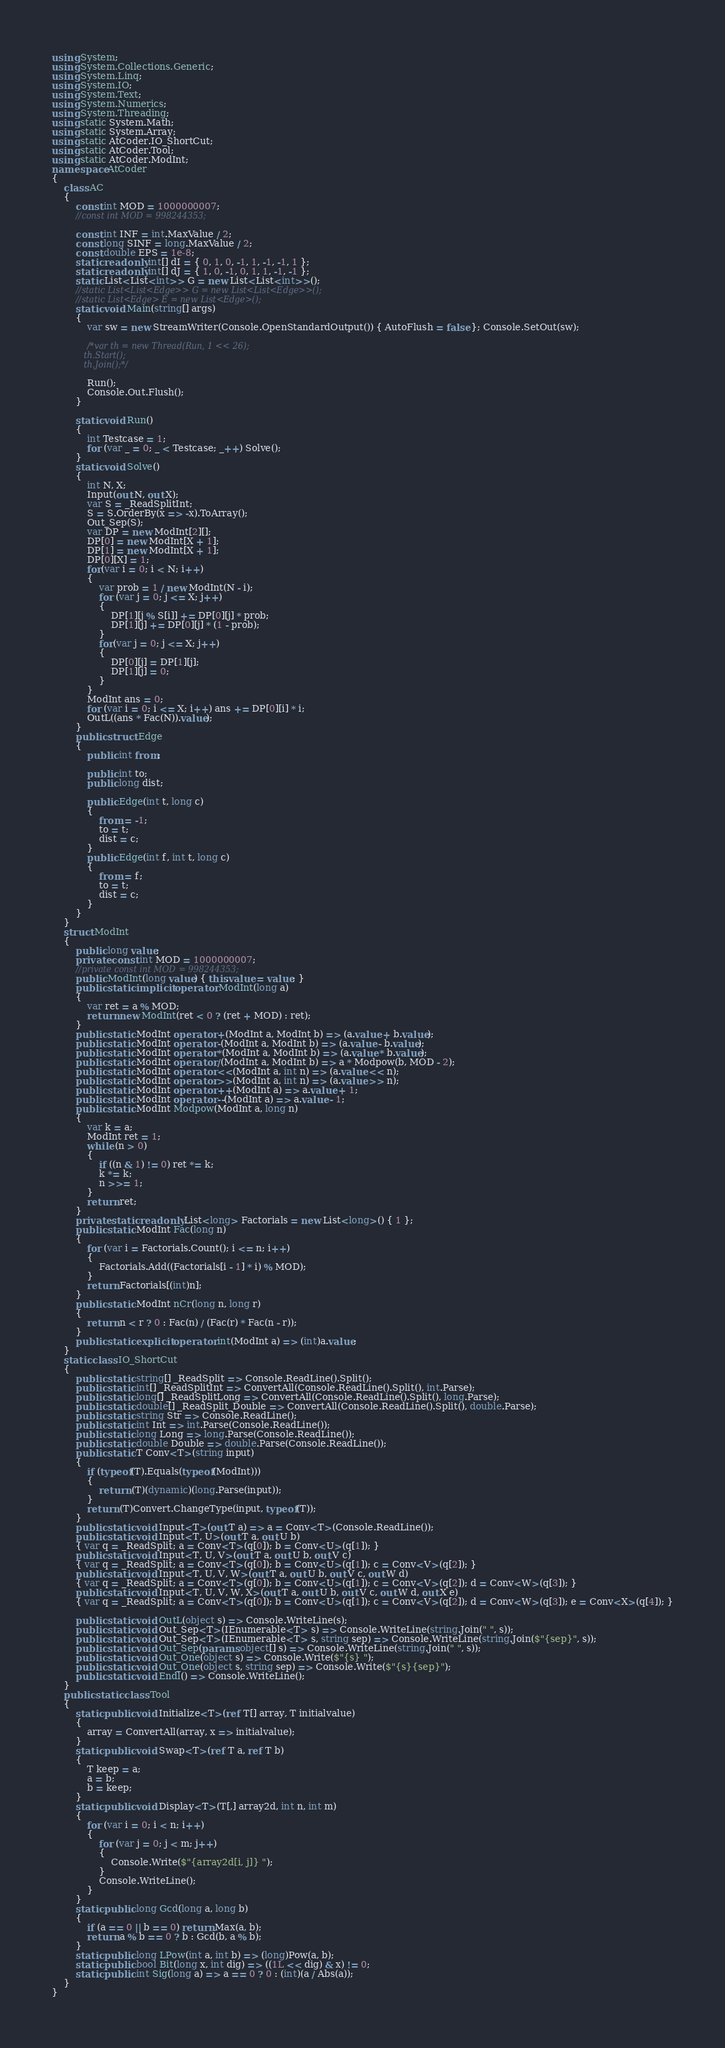Convert code to text. <code><loc_0><loc_0><loc_500><loc_500><_C#_>using System;
using System.Collections.Generic;
using System.Linq;
using System.IO;
using System.Text;
using System.Numerics;
using System.Threading;
using static System.Math;
using static System.Array;
using static AtCoder.IO_ShortCut;
using static AtCoder.Tool;
using static AtCoder.ModInt;
namespace AtCoder
{
    class AC
    {
        const int MOD = 1000000007;
        //const int MOD = 998244353;

        const int INF = int.MaxValue / 2;
        const long SINF = long.MaxValue / 2;
        const double EPS = 1e-8;
        static readonly int[] dI = { 0, 1, 0, -1, 1, -1, -1, 1 };
        static readonly int[] dJ = { 1, 0, -1, 0, 1, 1, -1, -1 };
        static List<List<int>> G = new List<List<int>>();
        //static List<List<Edge>> G = new List<List<Edge>>();
        //static List<Edge> E = new List<Edge>();
        static void Main(string[] args)
        {
            var sw = new StreamWriter(Console.OpenStandardOutput()) { AutoFlush = false }; Console.SetOut(sw);

            /*var th = new Thread(Run, 1 << 26);
            th.Start();
            th.Join();*/

            Run();
            Console.Out.Flush();
        }

        static void Run()
        {
            int Testcase = 1;
            for (var _ = 0; _ < Testcase; _++) Solve();
        }
        static void Solve()
        {
            int N, X;
            Input(out N, out X);
            var S = _ReadSplitInt;
            S = S.OrderBy(x => -x).ToArray();
            Out_Sep(S);
            var DP = new ModInt[2][];
            DP[0] = new ModInt[X + 1];
            DP[1] = new ModInt[X + 1];
            DP[0][X] = 1;
            for(var i = 0; i < N; i++)
            {
                var prob = 1 / new ModInt(N - i);
                for (var j = 0; j <= X; j++)
                {
                    DP[1][j % S[i]] += DP[0][j] * prob;
                    DP[1][j] += DP[0][j] * (1 - prob);
                }
                for(var j = 0; j <= X; j++)
                {
                    DP[0][j] = DP[1][j];
                    DP[1][j] = 0;
                }
            }
            ModInt ans = 0;
            for (var i = 0; i <= X; i++) ans += DP[0][i] * i;
            OutL((ans * Fac(N)).value);
        }
        public struct Edge
        {
            public int from;

            public int to;
            public long dist;

            public Edge(int t, long c)
            {
                from = -1;
                to = t;
                dist = c;
            }
            public Edge(int f, int t, long c)
            {
                from = f;
                to = t;
                dist = c;
            }
        }
    }
    struct ModInt
    {
        public long value;
        private const int MOD = 1000000007;
        //private const int MOD = 998244353;
        public ModInt(long value) { this.value = value; }
        public static implicit operator ModInt(long a)
        {
            var ret = a % MOD;
            return new ModInt(ret < 0 ? (ret + MOD) : ret);
        }
        public static ModInt operator +(ModInt a, ModInt b) => (a.value + b.value);
        public static ModInt operator -(ModInt a, ModInt b) => (a.value - b.value);
        public static ModInt operator *(ModInt a, ModInt b) => (a.value * b.value);
        public static ModInt operator /(ModInt a, ModInt b) => a * Modpow(b, MOD - 2);
        public static ModInt operator <<(ModInt a, int n) => (a.value << n);
        public static ModInt operator >>(ModInt a, int n) => (a.value >> n);
        public static ModInt operator ++(ModInt a) => a.value + 1;
        public static ModInt operator --(ModInt a) => a.value - 1;
        public static ModInt Modpow(ModInt a, long n)
        {
            var k = a;
            ModInt ret = 1;
            while (n > 0)
            {
                if ((n & 1) != 0) ret *= k;
                k *= k;
                n >>= 1;
            }
            return ret;
        }
        private static readonly List<long> Factorials = new List<long>() { 1 };
        public static ModInt Fac(long n)
        {
            for (var i = Factorials.Count(); i <= n; i++)
            {
                Factorials.Add((Factorials[i - 1] * i) % MOD);
            }
            return Factorials[(int)n];
        }
        public static ModInt nCr(long n, long r)
        {
            return n < r ? 0 : Fac(n) / (Fac(r) * Fac(n - r));
        }
        public static explicit operator int(ModInt a) => (int)a.value;
    }
    static class IO_ShortCut
    {
        public static string[] _ReadSplit => Console.ReadLine().Split();
        public static int[] _ReadSplitInt => ConvertAll(Console.ReadLine().Split(), int.Parse);
        public static long[] _ReadSplitLong => ConvertAll(Console.ReadLine().Split(), long.Parse);
        public static double[] _ReadSplit_Double => ConvertAll(Console.ReadLine().Split(), double.Parse);
        public static string Str => Console.ReadLine();
        public static int Int => int.Parse(Console.ReadLine());
        public static long Long => long.Parse(Console.ReadLine());
        public static double Double => double.Parse(Console.ReadLine());
        public static T Conv<T>(string input)
        {
            if (typeof(T).Equals(typeof(ModInt)))
            {
                return (T)(dynamic)(long.Parse(input));
            }
            return (T)Convert.ChangeType(input, typeof(T));
        }
        public static void Input<T>(out T a) => a = Conv<T>(Console.ReadLine());
        public static void Input<T, U>(out T a, out U b)
        { var q = _ReadSplit; a = Conv<T>(q[0]); b = Conv<U>(q[1]); }
        public static void Input<T, U, V>(out T a, out U b, out V c)
        { var q = _ReadSplit; a = Conv<T>(q[0]); b = Conv<U>(q[1]); c = Conv<V>(q[2]); }
        public static void Input<T, U, V, W>(out T a, out U b, out V c, out W d)
        { var q = _ReadSplit; a = Conv<T>(q[0]); b = Conv<U>(q[1]); c = Conv<V>(q[2]); d = Conv<W>(q[3]); }
        public static void Input<T, U, V, W, X>(out T a, out U b, out V c, out W d, out X e)
        { var q = _ReadSplit; a = Conv<T>(q[0]); b = Conv<U>(q[1]); c = Conv<V>(q[2]); d = Conv<W>(q[3]); e = Conv<X>(q[4]); }

        public static void OutL(object s) => Console.WriteLine(s);
        public static void Out_Sep<T>(IEnumerable<T> s) => Console.WriteLine(string.Join(" ", s));
        public static void Out_Sep<T>(IEnumerable<T> s, string sep) => Console.WriteLine(string.Join($"{sep}", s));
        public static void Out_Sep(params object[] s) => Console.WriteLine(string.Join(" ", s));
        public static void Out_One(object s) => Console.Write($"{s} ");
        public static void Out_One(object s, string sep) => Console.Write($"{s}{sep}");
        public static void Endl() => Console.WriteLine();
    }
    public static class Tool
    {
        static public void Initialize<T>(ref T[] array, T initialvalue)
        {
            array = ConvertAll(array, x => initialvalue);
        }
        static public void Swap<T>(ref T a, ref T b)
        {
            T keep = a;
            a = b;
            b = keep;
        }
        static public void Display<T>(T[,] array2d, int n, int m)
        {
            for (var i = 0; i < n; i++)
            {
                for (var j = 0; j < m; j++)
                {
                    Console.Write($"{array2d[i, j]} ");
                }
                Console.WriteLine();
            }
        }
        static public long Gcd(long a, long b)
        {
            if (a == 0 || b == 0) return Max(a, b);
            return a % b == 0 ? b : Gcd(b, a % b);
        }
        static public long LPow(int a, int b) => (long)Pow(a, b);
        static public bool Bit(long x, int dig) => ((1L << dig) & x) != 0;
        static public int Sig(long a) => a == 0 ? 0 : (int)(a / Abs(a));
    }
}
</code> 